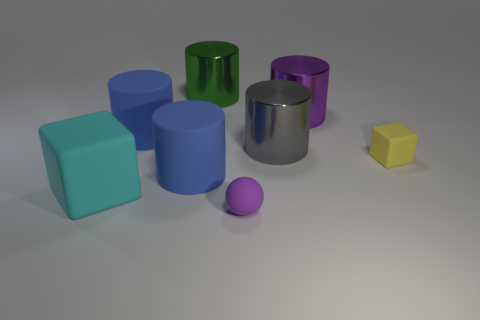Add 2 green shiny objects. How many objects exist? 10 Subtract all blue spheres. How many blue cylinders are left? 2 Subtract all large purple metallic cylinders. How many cylinders are left? 4 Subtract all green cylinders. How many cylinders are left? 4 Subtract all cylinders. How many objects are left? 3 Add 5 big matte cylinders. How many big matte cylinders exist? 7 Subtract 0 blue balls. How many objects are left? 8 Subtract all red cubes. Subtract all yellow balls. How many cubes are left? 2 Subtract all gray metallic objects. Subtract all large gray blocks. How many objects are left? 7 Add 4 tiny yellow matte cubes. How many tiny yellow matte cubes are left? 5 